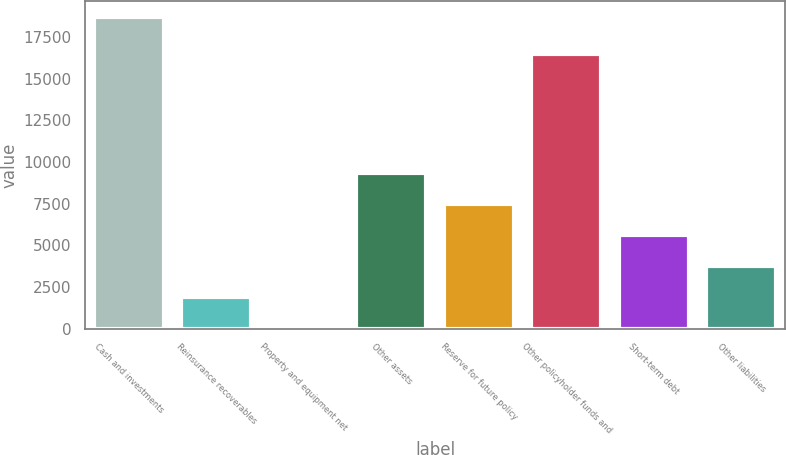Convert chart. <chart><loc_0><loc_0><loc_500><loc_500><bar_chart><fcel>Cash and investments<fcel>Reinsurance recoverables<fcel>Property and equipment net<fcel>Other assets<fcel>Reserve for future policy<fcel>Other policyholder funds and<fcel>Short-term debt<fcel>Other liabilities<nl><fcel>18733<fcel>1889.5<fcel>18<fcel>9375.5<fcel>7504<fcel>16465<fcel>5632.5<fcel>3761<nl></chart> 